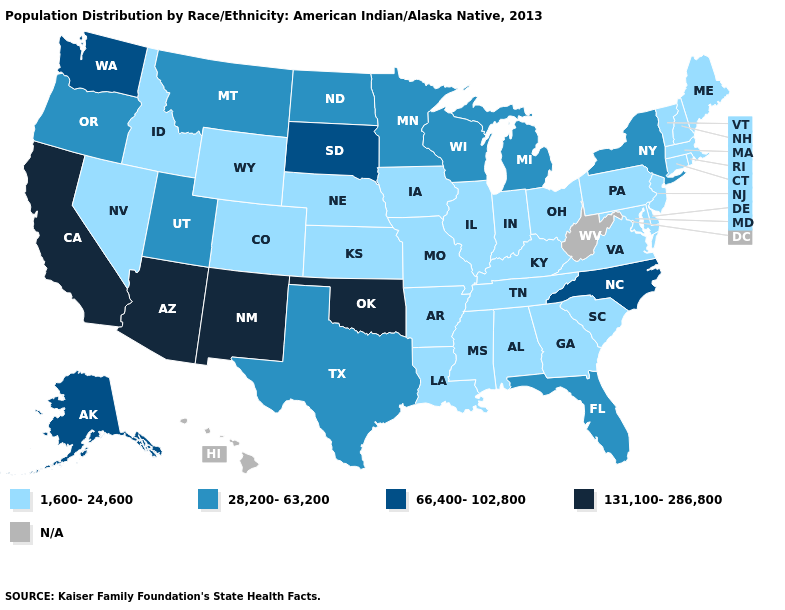Name the states that have a value in the range 66,400-102,800?
Short answer required. Alaska, North Carolina, South Dakota, Washington. Name the states that have a value in the range N/A?
Short answer required. Hawaii, West Virginia. Does South Dakota have the highest value in the USA?
Answer briefly. No. What is the lowest value in the MidWest?
Keep it brief. 1,600-24,600. Name the states that have a value in the range 66,400-102,800?
Short answer required. Alaska, North Carolina, South Dakota, Washington. What is the lowest value in states that border Nevada?
Answer briefly. 1,600-24,600. Name the states that have a value in the range N/A?
Short answer required. Hawaii, West Virginia. Name the states that have a value in the range N/A?
Give a very brief answer. Hawaii, West Virginia. What is the value of Rhode Island?
Short answer required. 1,600-24,600. Which states hav the highest value in the South?
Keep it brief. Oklahoma. Name the states that have a value in the range N/A?
Give a very brief answer. Hawaii, West Virginia. Among the states that border New Mexico , does Texas have the lowest value?
Give a very brief answer. No. What is the lowest value in states that border Iowa?
Answer briefly. 1,600-24,600. What is the value of Idaho?
Give a very brief answer. 1,600-24,600. 